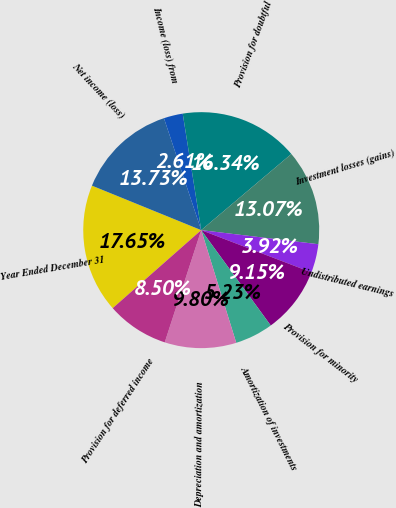Convert chart to OTSL. <chart><loc_0><loc_0><loc_500><loc_500><pie_chart><fcel>Year Ended December 31<fcel>Net income (loss)<fcel>Income (loss) from<fcel>Provision for doubtful<fcel>Investment losses (gains)<fcel>Undistributed earnings<fcel>Provision for minority<fcel>Amortization of investments<fcel>Depreciation and amortization<fcel>Provision for deferred income<nl><fcel>17.65%<fcel>13.73%<fcel>2.61%<fcel>16.34%<fcel>13.07%<fcel>3.92%<fcel>9.15%<fcel>5.23%<fcel>9.8%<fcel>8.5%<nl></chart> 